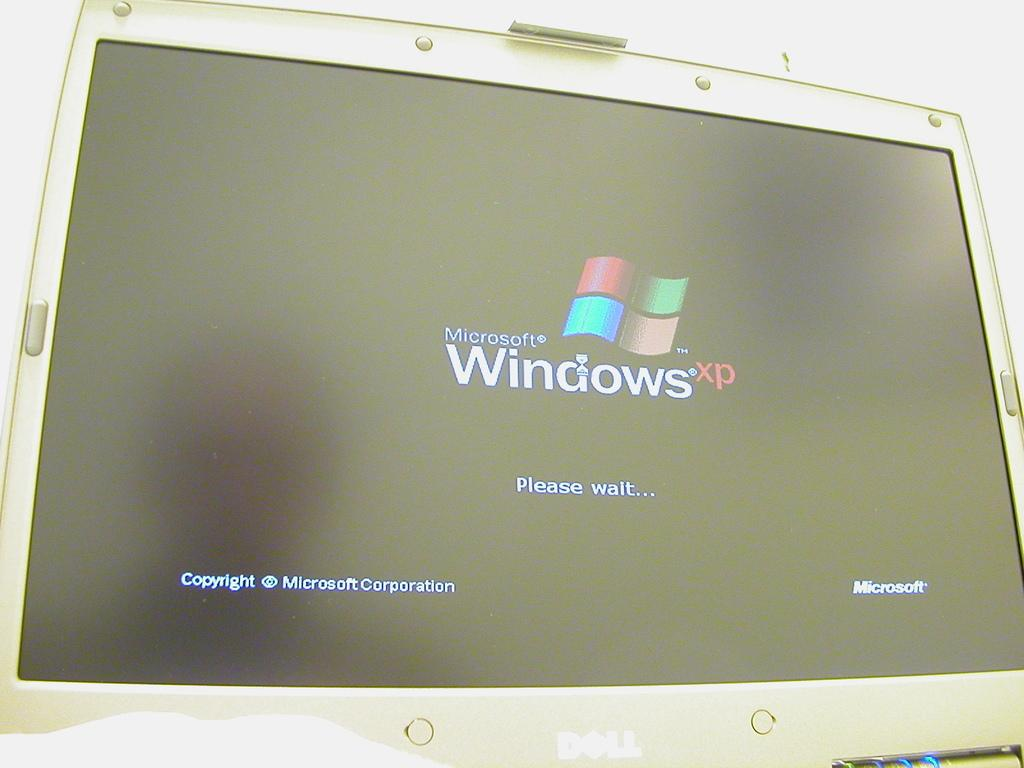Provide a one-sentence caption for the provided image. A computer monitor showing the starting screen for Microsoft Windows XP. 